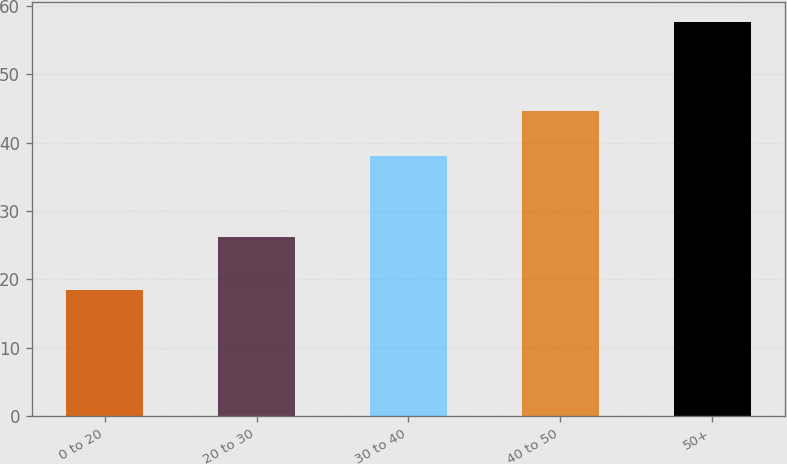Convert chart. <chart><loc_0><loc_0><loc_500><loc_500><bar_chart><fcel>0 to 20<fcel>20 to 30<fcel>30 to 40<fcel>40 to 50<fcel>50+<nl><fcel>18.37<fcel>26.15<fcel>38.05<fcel>44.59<fcel>57.71<nl></chart> 